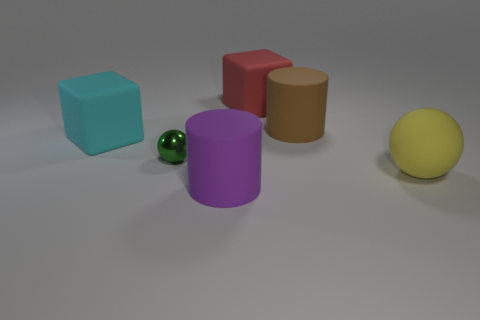What time of day does the lighting in the image suggest? The lighting in the image doesn't suggest a specific time of day. It appears to be an artificial and uniform light source, as it casts soft shadows beneath the objects, typical of studio lighting. 